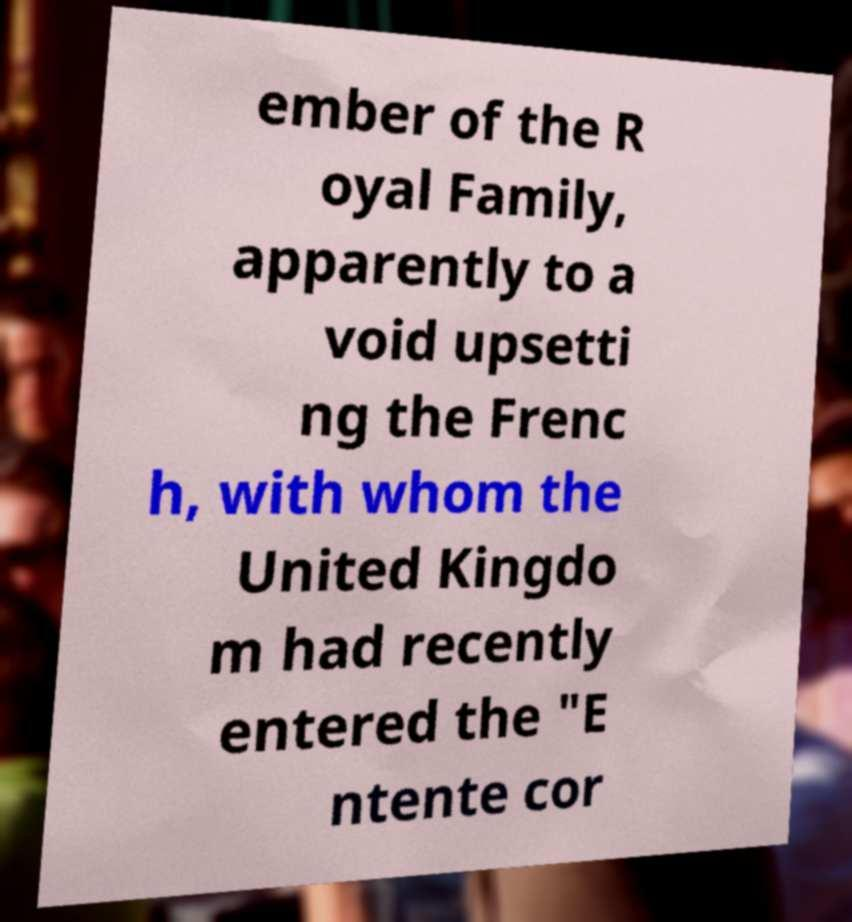For documentation purposes, I need the text within this image transcribed. Could you provide that? ember of the R oyal Family, apparently to a void upsetti ng the Frenc h, with whom the United Kingdo m had recently entered the "E ntente cor 